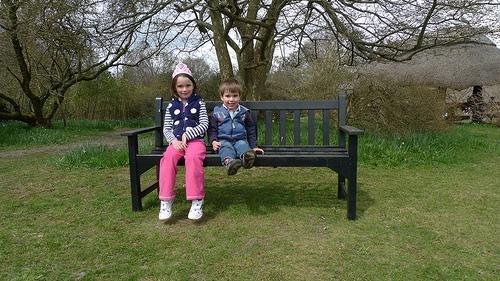How many people are in the picture?
Give a very brief answer. 2. 